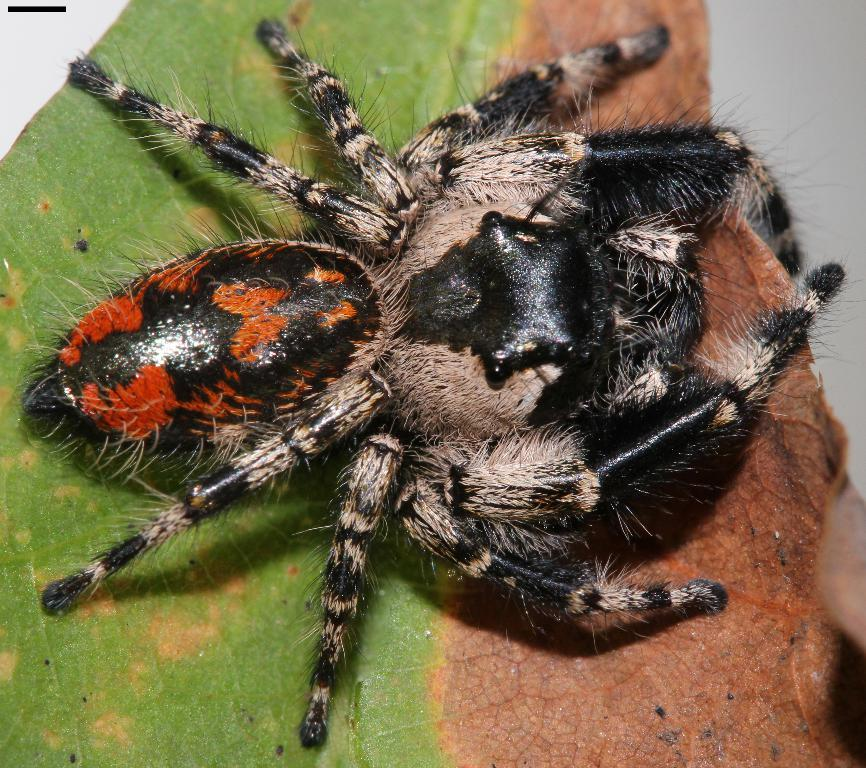What is the main subject of the image? There is a spider in the image. Where is the spider located? The spider is on a leaf. What type of bottle is the spider using to perform addition in the image? There is no bottle or addition activity present in the image; it features a spider on a leaf. Can you tell me the color of the sock that the spider is wearing in the image? There is no sock present in the image, as the spider is on a leaf. 